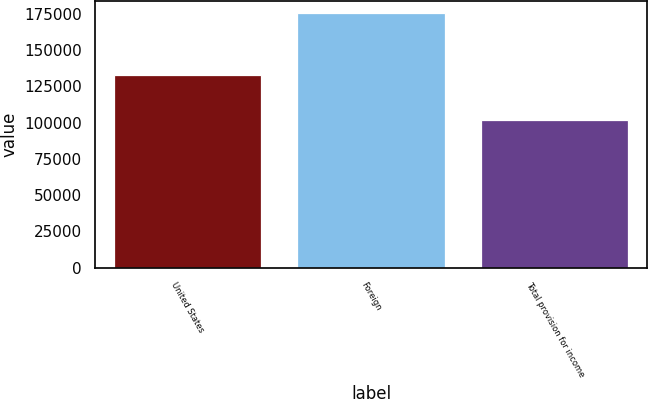<chart> <loc_0><loc_0><loc_500><loc_500><bar_chart><fcel>United States<fcel>Foreign<fcel>Total provision for income<nl><fcel>132715<fcel>175253<fcel>101629<nl></chart> 